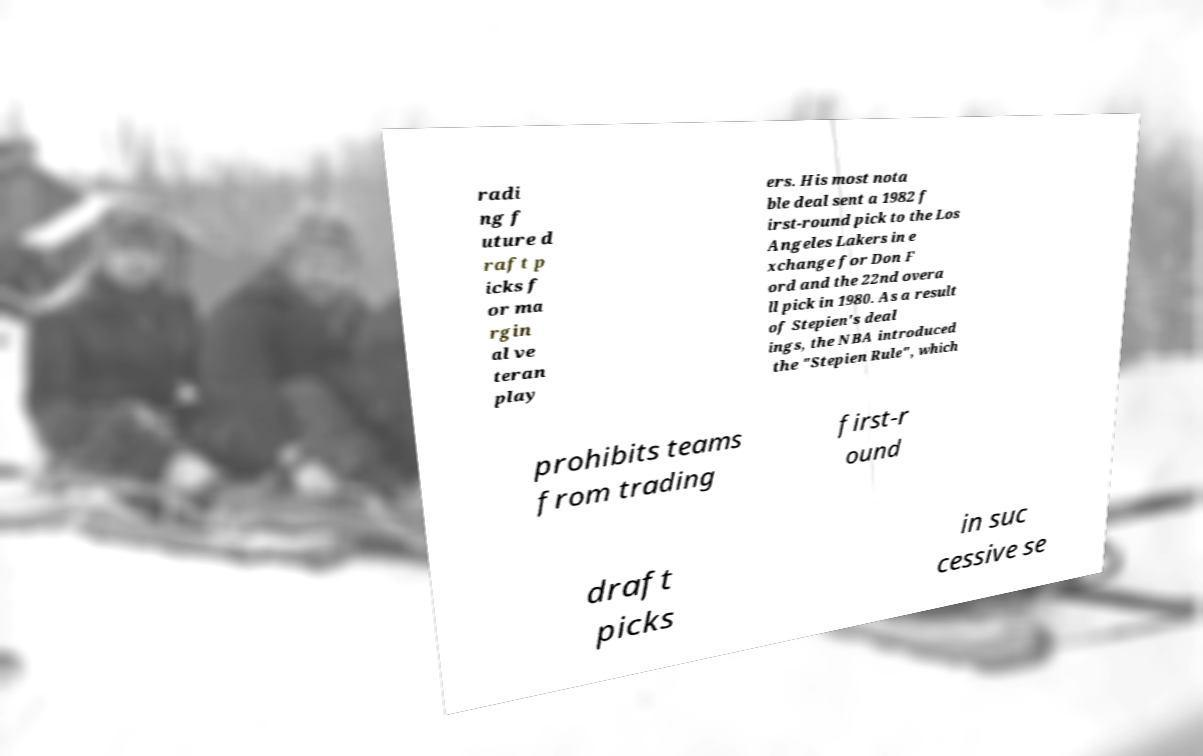What messages or text are displayed in this image? I need them in a readable, typed format. radi ng f uture d raft p icks f or ma rgin al ve teran play ers. His most nota ble deal sent a 1982 f irst-round pick to the Los Angeles Lakers in e xchange for Don F ord and the 22nd overa ll pick in 1980. As a result of Stepien's deal ings, the NBA introduced the "Stepien Rule", which prohibits teams from trading first-r ound draft picks in suc cessive se 